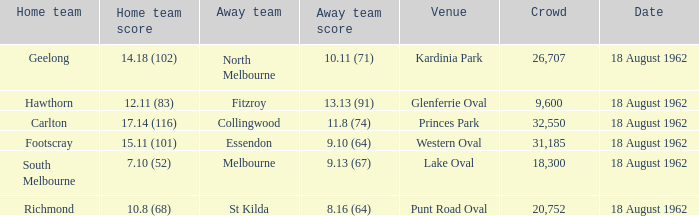What was the away team when the home team scored 10.8 (68)? St Kilda. 